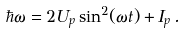Convert formula to latex. <formula><loc_0><loc_0><loc_500><loc_500>\hbar { \omega } = 2 U _ { p } \sin ^ { 2 } ( \omega t ) + I _ { p } \, .</formula> 